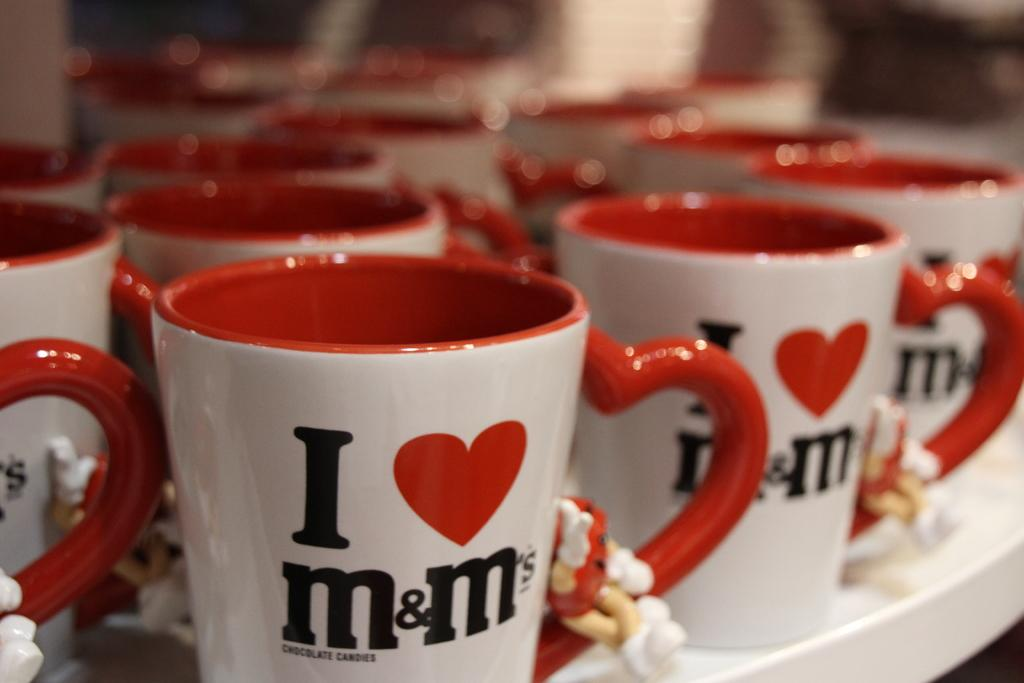What objects are visible in the image? There are tea mugs in the image. Where are the tea mugs located? The tea mugs are on a table. What colors can be seen on the tea mugs? The tea mugs are in red and white colors. What belief is represented by the harmony of the tea mugs' operation in the image? There is no representation of a belief or harmony of operation in the image, as it only features tea mugs on a table in red and white colors. 